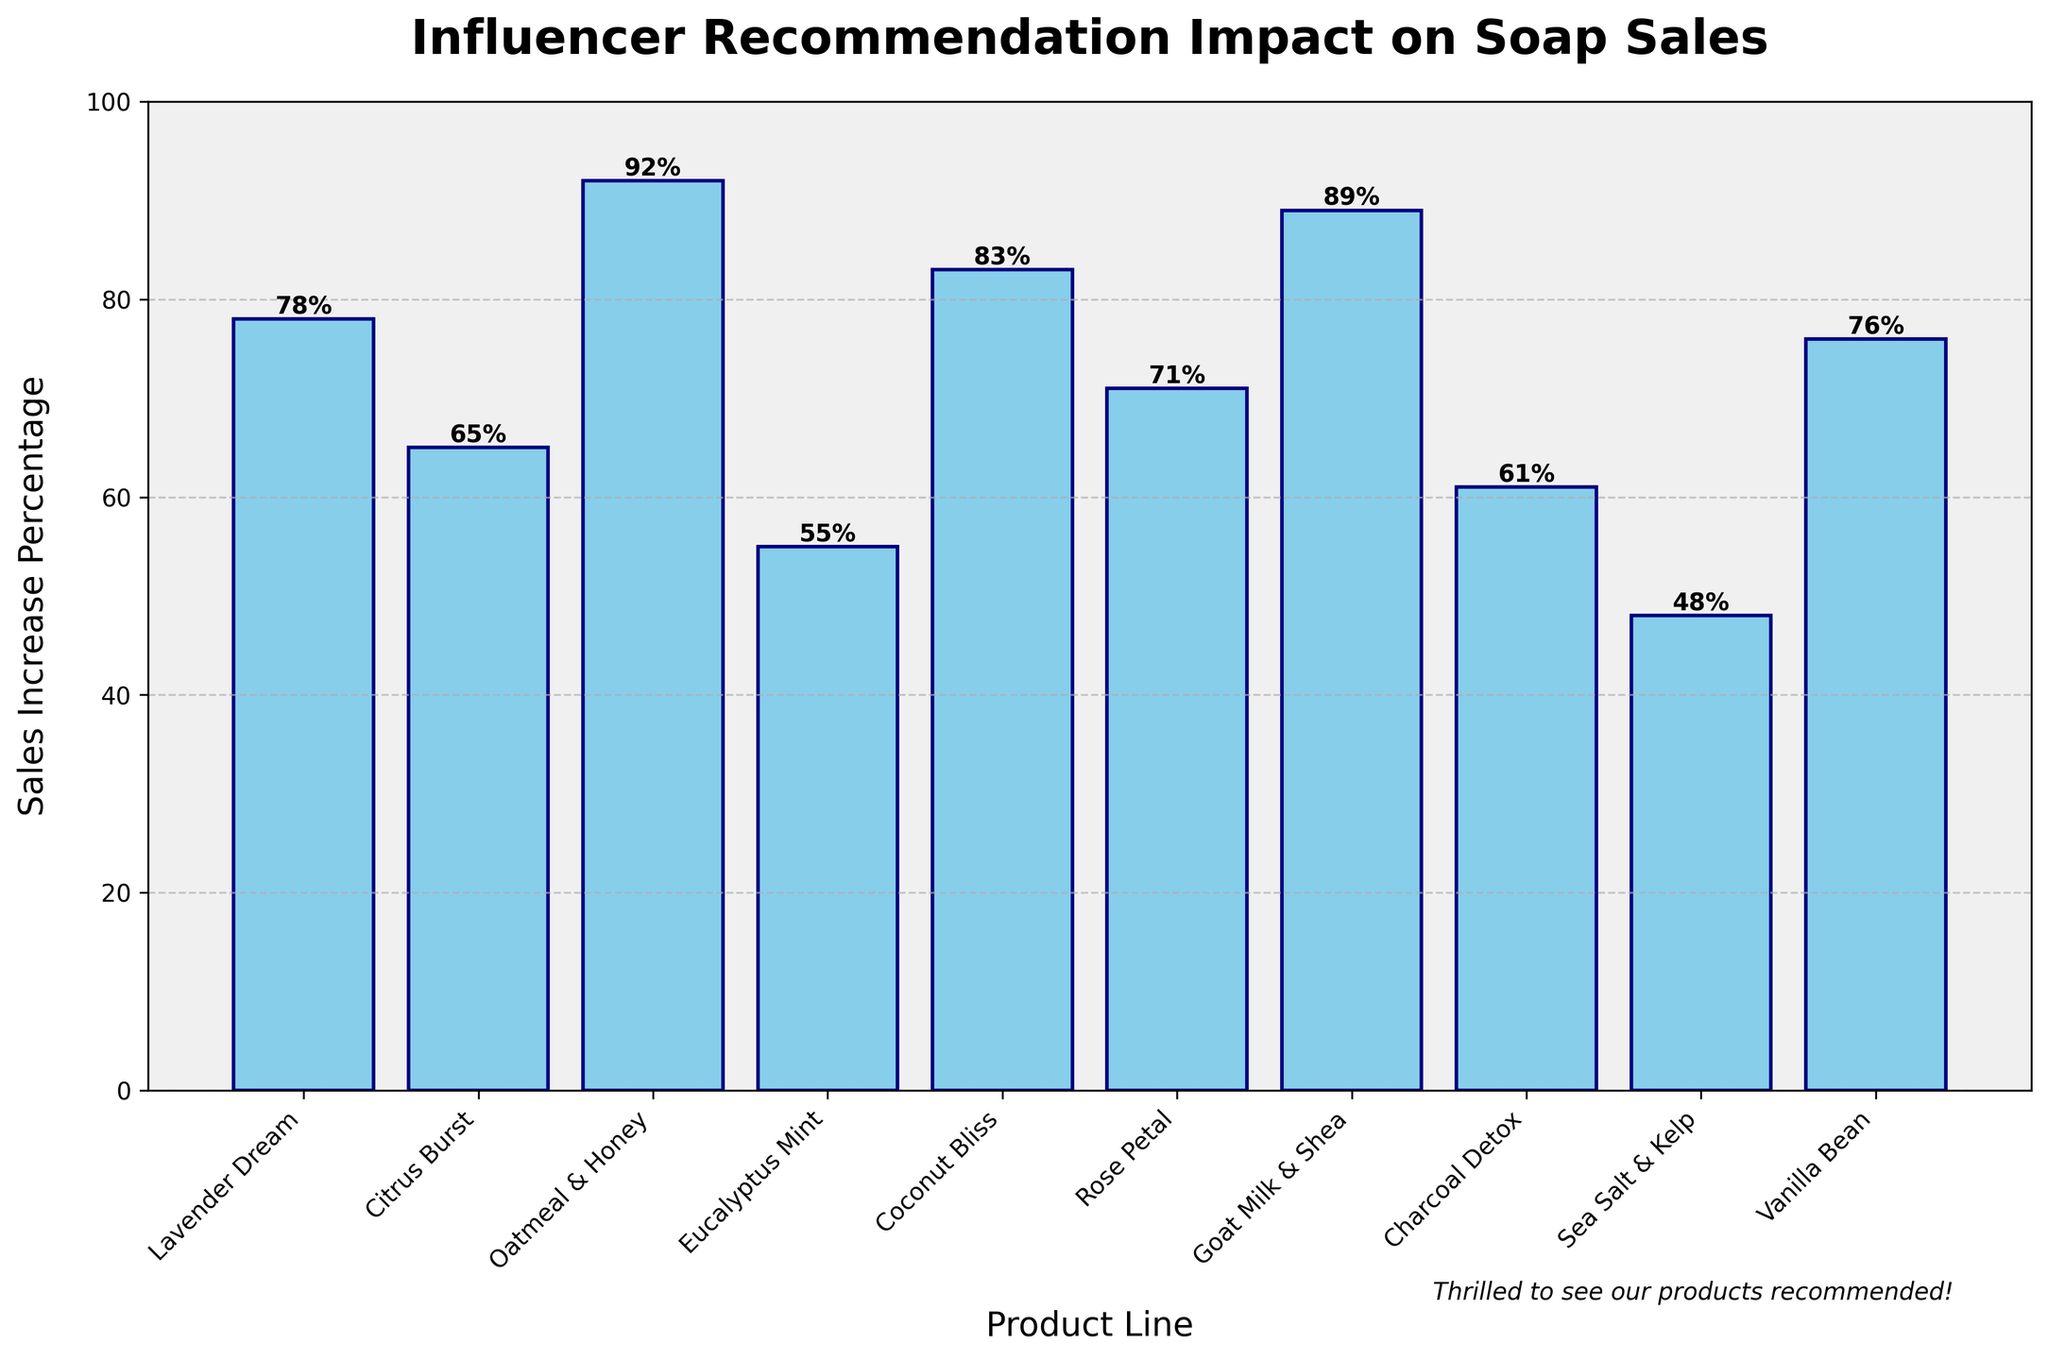What's the product line with the largest sales increase percentage? The bar chart shows that the "Oatmeal & Honey" product line has the highest bar, indicating the largest sales increase percentage.
Answer: Oatmeal & Honey What's the difference in sales increase between Coconut Bliss and Eucalyptus Mint? The sales increase for Coconut Bliss is 83%, and for Eucalyptus Mint, it is 55%. The difference is calculated as 83% - 55% = 28%.
Answer: 28% Which product lines have a sales increase percentage greater than 75%? The bars corresponding to Lavender Dream (78%), Coconut Bliss (83%), Oatmeal & Honey (92%), Goat Milk & Shea (89%), and Vanilla Bean (76%) all exceed 75%.
Answer: Lavender Dream, Coconut Bliss, Oatmeal & Honey, Goat Milk & Shea, Vanilla Bean What's the average sales increase percentage of all product lines? To find the average, sum all the sales increase percentages (78 + 65 + 92 + 55 + 83 + 71 + 89 + 61 + 48 + 76 = 718) and divide by the number of product lines (10). The average is 718 / 10 = 71.8%.
Answer: 71.8% What’s the cumulative sales increase percentage of the bottom three product lines? The sales increase percentages for the bottom three product lines are Eucalyptus Mint (55%), Sea Salt & Kelp (48%), and Charcoal Detox (61%). Summing these gives 55% + 48% + 61% = 164%.
Answer: 164% How does the sales increase of Rose Petal compare to that of Citrus Burst? The sales increase percentages for Rose Petal and Citrus Burst are 71% and 65% respectively. Since 71% is greater than 65%, Rose Petal has a higher increase.
Answer: Rose Petal has a higher increase Which product line has the least sales increase percentage, and what is it? The shortest bar in the chart represents Sea Salt & Kelp with the smallest sales increase percentage of 48%.
Answer: Sea Salt & Kelp with 48% What is the median sales increase percentage among all product lines? The dataset has 10 values. After sorting (48, 55, 61, 65, 71, 76, 78, 83, 89, 92), the middle values are the 5th and 6th; hence the median is (71 + 76) / 2 = 73.5%.
Answer: 73.5% Which three product lines fall around the median sales increase percentage? The three product lines closest to the median (73.5%) are Rose Petal (71%), Vanilla Bean (76%), and Lavender Dream (78%).
Answer: Rose Petal, Vanilla Bean, Lavender Dream 